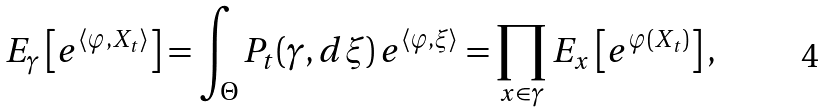Convert formula to latex. <formula><loc_0><loc_0><loc_500><loc_500>E _ { \gamma } \left [ e ^ { \langle \varphi , X _ { t } \rangle } \right ] = \int _ { \Theta } P _ { t } ( \gamma , d \xi ) \, e ^ { \langle \varphi , \xi \rangle } = \prod _ { x \in \gamma } E _ { x } \left [ e ^ { \varphi ( X _ { t } ) } \right ] ,</formula> 